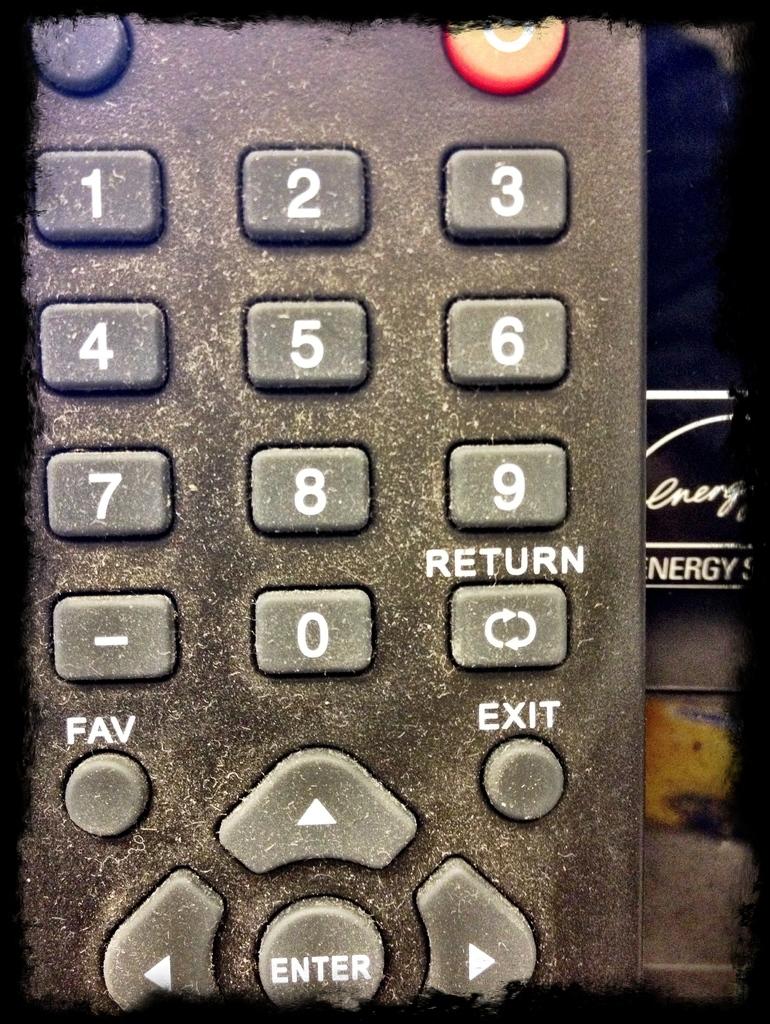What is the function of the round button all the way at the bottom of the photo?
Your answer should be compact. Enter. 